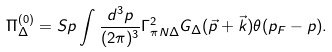Convert formula to latex. <formula><loc_0><loc_0><loc_500><loc_500>\Pi ^ { ( 0 ) } _ { \Delta } = S p \int \frac { d ^ { 3 } p } { ( 2 \pi ) ^ { 3 } } \Gamma ^ { 2 } _ { \pi N \Delta } G _ { \Delta } ( \vec { p } + \vec { k } ) \theta ( p _ { F } - p ) .</formula> 